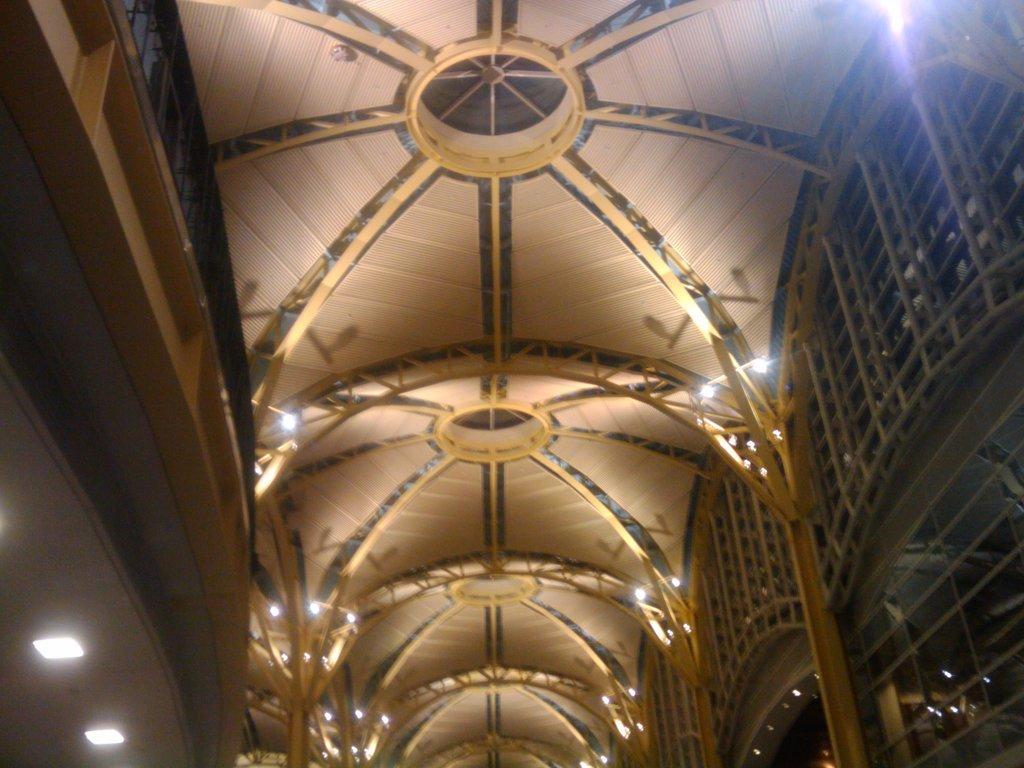What type of location is depicted in the image? The image shows an inside view of a building. What objects can be seen in the image? There are poles and lights visible in the image. Can you see a boat in the image? No, there is no boat present in the image. What act is being performed by the lights in the image? The lights are not performing any act; they are simply providing illumination in the building. 